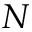Convert formula to latex. <formula><loc_0><loc_0><loc_500><loc_500>N</formula> 